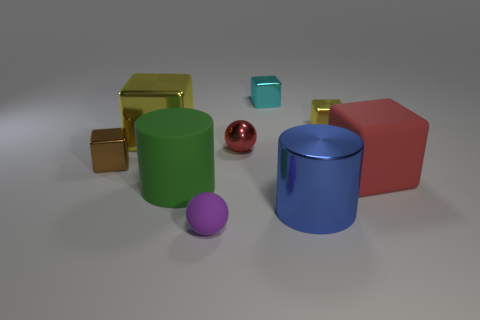There is a ball that is the same color as the rubber block; what material is it?
Ensure brevity in your answer.  Metal. Are there any other things that have the same shape as the big red object?
Provide a short and direct response. Yes. The small object that is in front of the big rubber thing that is behind the large matte thing left of the red matte thing is what shape?
Your answer should be very brief. Sphere. The blue thing has what shape?
Ensure brevity in your answer.  Cylinder. The large thing that is behind the big red thing is what color?
Offer a terse response. Yellow. Is the size of the cube that is in front of the brown shiny thing the same as the cyan cube?
Keep it short and to the point. No. There is a green object that is the same shape as the big blue metal object; what size is it?
Your response must be concise. Large. Are there any other things that are the same size as the green matte cylinder?
Provide a succinct answer. Yes. Do the small cyan metallic object and the purple matte thing have the same shape?
Provide a short and direct response. No. Are there fewer tiny brown metal blocks that are right of the small yellow cube than things that are in front of the matte sphere?
Provide a succinct answer. No. 